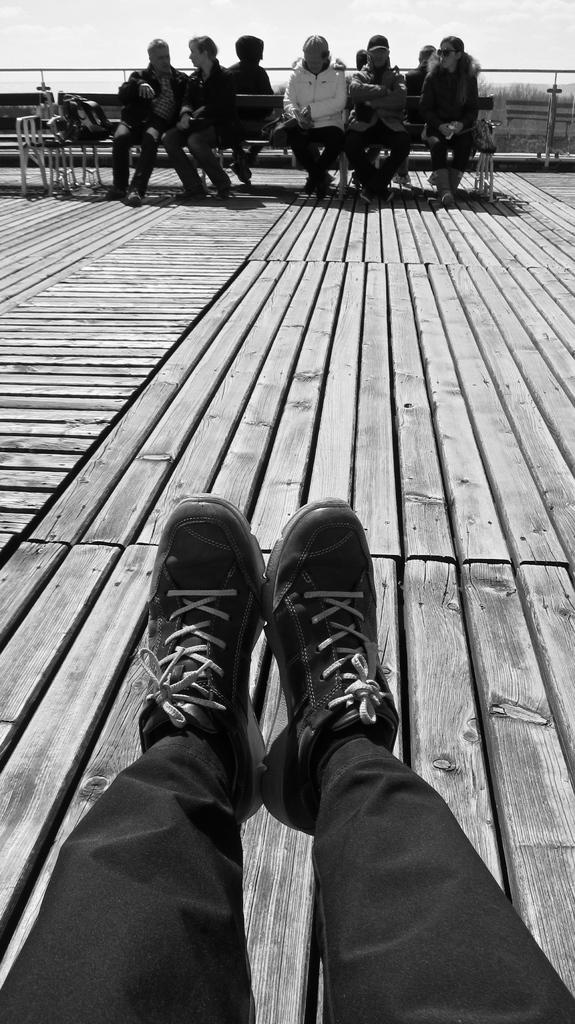What is the color scheme of the image? The image is black and white. How many people can be seen in the image? There are a few people in the image. What are the benches in the image used for? The benches have objects on them, suggesting they might be used for sitting or displaying items. What type of surface is present in the image? There is a wooden surface in the image. What is the purpose of the fence in the image? The fence might be used to enclose an area or provide a boundary. What can be seen in the sky in the image? The sky is visible in the image, but no specific details about the sky can be determined from the provided facts. What type of chin can be seen on the cannon in the image? There is no cannon present in the image, and therefore no chin can be observed. What is the mass of the objects on the benches in the image? The provided facts do not give any information about the mass of the objects on the benches, so it cannot be determined from the image. 